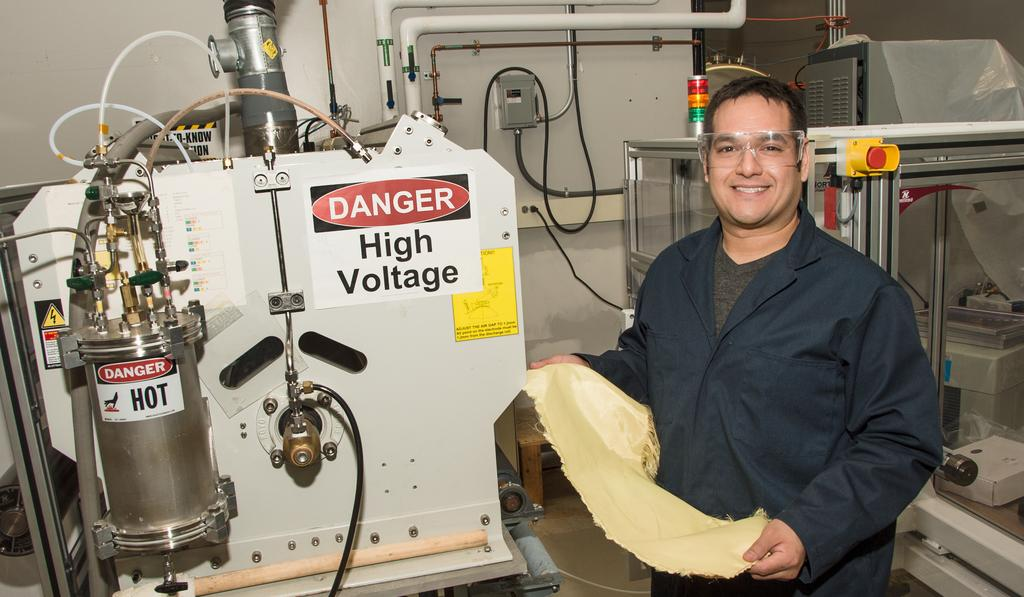What can be seen in the image? There is a person in the image. What is the person wearing? The person is wearing a shirt. What is the person holding in their hand? The person is holding an item in their hand. What can be seen in the background of the image? There are machines, pipes, and cables in the background of the image. How many sisters does the person in the image have? There is no information about the person's sisters in the image. What country is the person in the image from? There is no information about the person's country of origin in the image. 